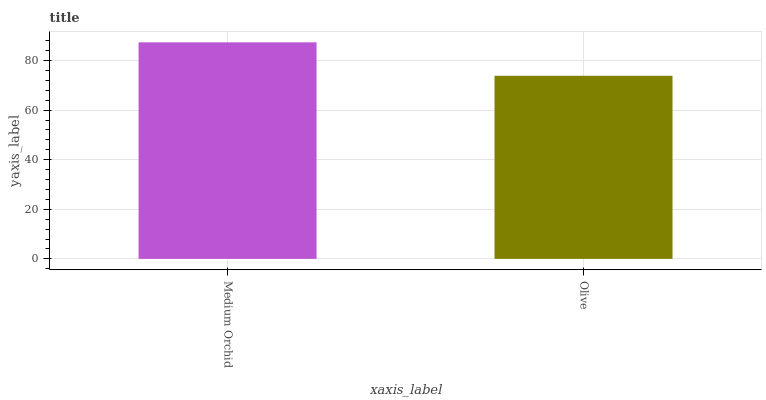Is Olive the minimum?
Answer yes or no. Yes. Is Medium Orchid the maximum?
Answer yes or no. Yes. Is Olive the maximum?
Answer yes or no. No. Is Medium Orchid greater than Olive?
Answer yes or no. Yes. Is Olive less than Medium Orchid?
Answer yes or no. Yes. Is Olive greater than Medium Orchid?
Answer yes or no. No. Is Medium Orchid less than Olive?
Answer yes or no. No. Is Medium Orchid the high median?
Answer yes or no. Yes. Is Olive the low median?
Answer yes or no. Yes. Is Olive the high median?
Answer yes or no. No. Is Medium Orchid the low median?
Answer yes or no. No. 